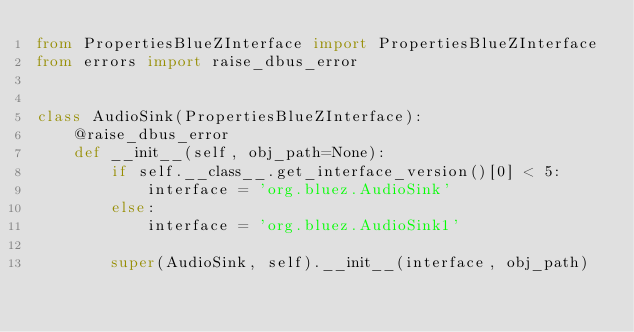Convert code to text. <code><loc_0><loc_0><loc_500><loc_500><_Python_>from PropertiesBlueZInterface import PropertiesBlueZInterface
from errors import raise_dbus_error


class AudioSink(PropertiesBlueZInterface):
    @raise_dbus_error
    def __init__(self, obj_path=None):
        if self.__class__.get_interface_version()[0] < 5:
            interface = 'org.bluez.AudioSink'
        else:
            interface = 'org.bluez.AudioSink1'

        super(AudioSink, self).__init__(interface, obj_path)
</code> 